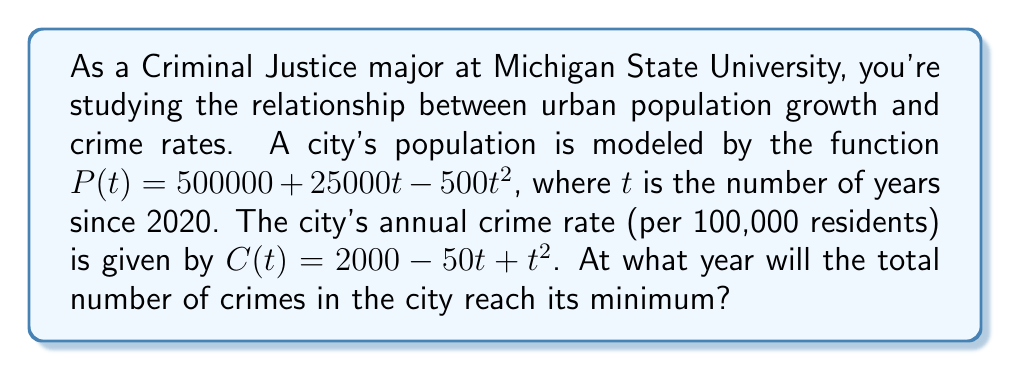Show me your answer to this math problem. To solve this problem, we need to follow these steps:

1) First, we need to find the total number of crimes as a function of time. This is given by multiplying the population by the crime rate (per 100,000 residents) and dividing by 100,000:

   $T(t) = \frac{P(t) \cdot C(t)}{100000}$

2) Substituting the given functions:

   $T(t) = \frac{(500000 + 25000t - 500t^2)(2000 - 50t + t^2)}{100000}$

3) Expanding this expression:

   $T(t) = 10000 + 250t - 10t^2 + 500t - 12.5t^2 + 0.25t^3 - 10t^2 + 0.25t^3 - 0.005t^4$

4) Simplifying:

   $T(t) = 10000 + 750t - 32.5t^2 + 0.5t^3 - 0.005t^4$

5) To find the minimum, we need to find where the derivative of this function equals zero:

   $T'(t) = 750 - 65t + 1.5t^2 - 0.02t^3$

6) Setting this equal to zero:

   $750 - 65t + 1.5t^2 - 0.02t^3 = 0$

7) This cubic equation is difficult to solve analytically. We can use numerical methods or a graphing calculator to find that the solution is approximately $t = 11.68$.

8) Since $t$ represents years since 2020, the minimum occurs in 2031 (rounding to the nearest year).
Answer: 2031 